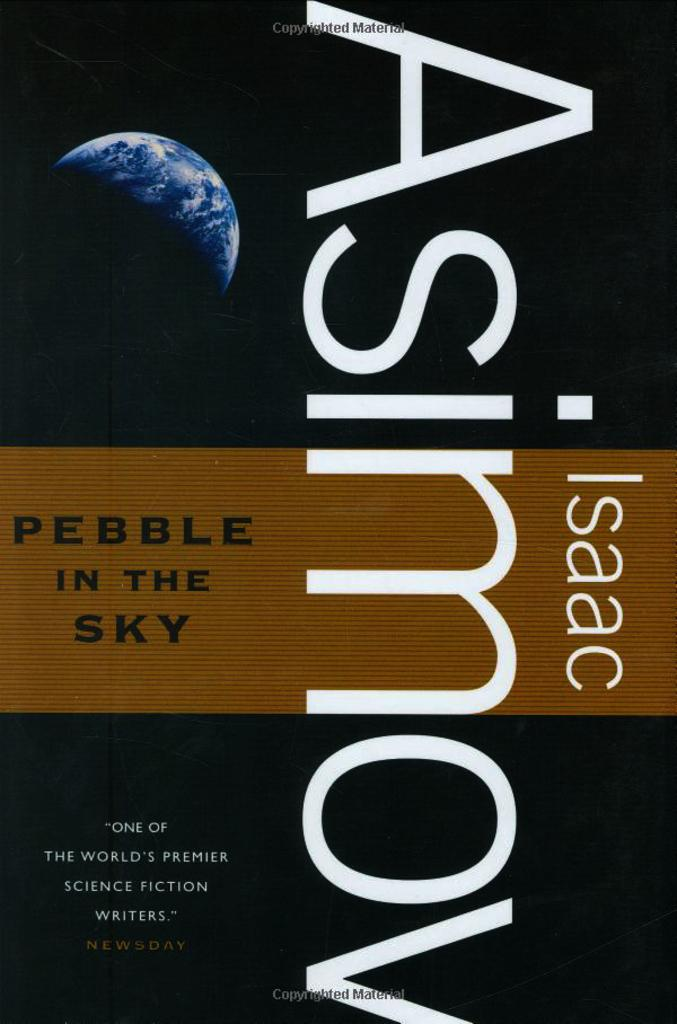What is the main subject of the image? There is a poster or book cover in the image. What colors are used on the poster or book cover? The poster or book cover has black and brown colors. Is there any text on the poster or book cover? Yes, there is text written on the poster or book cover. Can you tell me how many cents are depicted on the poster or book cover? There are no cents depicted on the poster or book cover; it features black and brown colors and text. What type of guitar is shown on the poster or book cover? There is no guitar present on the poster or book cover; it only has black and brown colors and text. 